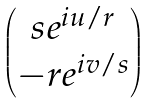<formula> <loc_0><loc_0><loc_500><loc_500>\begin{pmatrix} s e ^ { i u / r } \\ - r e ^ { i v / s } \end{pmatrix}</formula> 